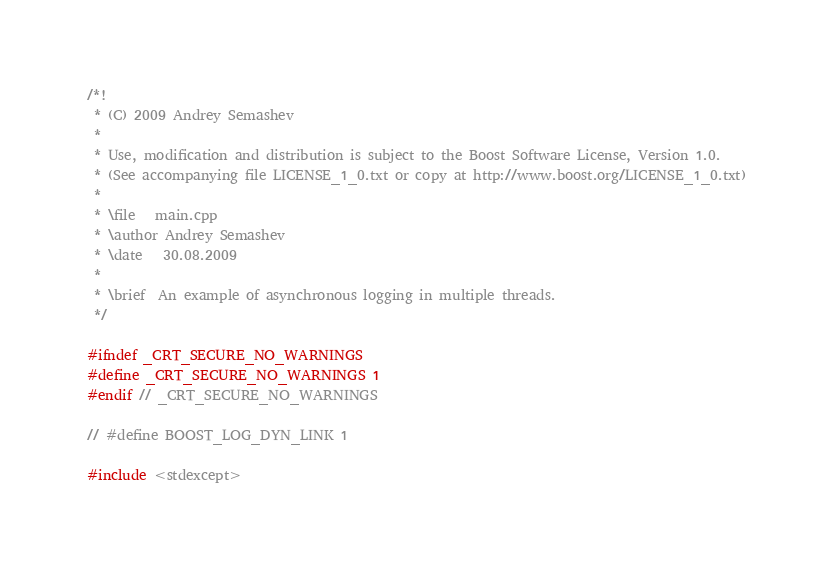<code> <loc_0><loc_0><loc_500><loc_500><_C++_>/*!
 * (C) 2009 Andrey Semashev
 *
 * Use, modification and distribution is subject to the Boost Software License, Version 1.0.
 * (See accompanying file LICENSE_1_0.txt or copy at http://www.boost.org/LICENSE_1_0.txt)
 *
 * \file   main.cpp
 * \author Andrey Semashev
 * \date   30.08.2009
 *
 * \brief  An example of asynchronous logging in multiple threads.
 */

#ifndef _CRT_SECURE_NO_WARNINGS
#define _CRT_SECURE_NO_WARNINGS 1
#endif // _CRT_SECURE_NO_WARNINGS

// #define BOOST_LOG_DYN_LINK 1

#include <stdexcept></code> 